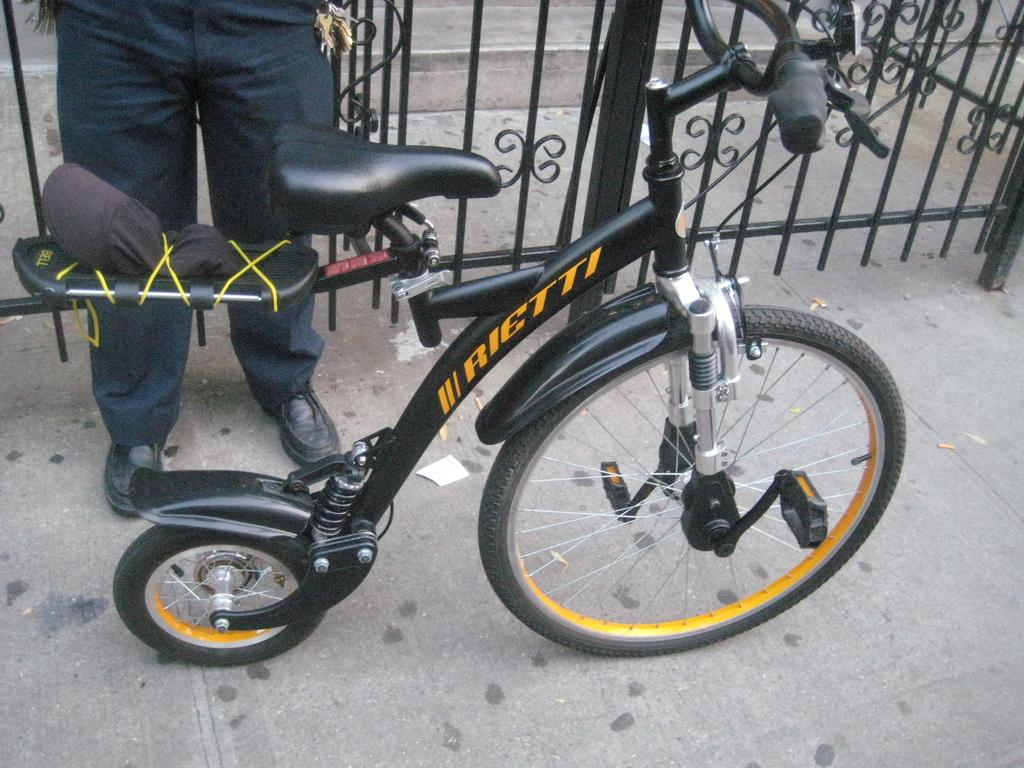What is the main object in the image? There is a cycle in the image. Who is present in the image? There is a person standing behind the cycle. What is the location of the person in relation to the cycle? The person is standing behind the cycle. What is the background of the image? The person is in front of a gate. What type of liquid or juice is being used as bait in the image? There is no liquid, juice, or bait present in the image. 